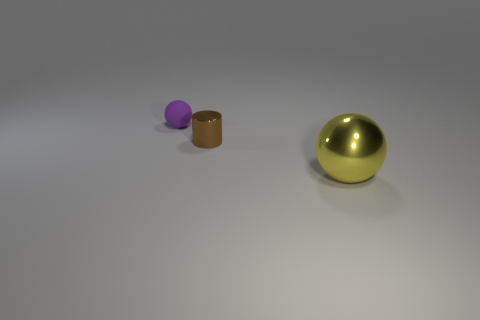Add 1 shiny objects. How many objects exist? 4 Subtract all spheres. How many objects are left? 1 Add 2 tiny spheres. How many tiny spheres are left? 3 Add 2 purple objects. How many purple objects exist? 3 Subtract 0 brown spheres. How many objects are left? 3 Subtract all small gray matte objects. Subtract all small purple spheres. How many objects are left? 2 